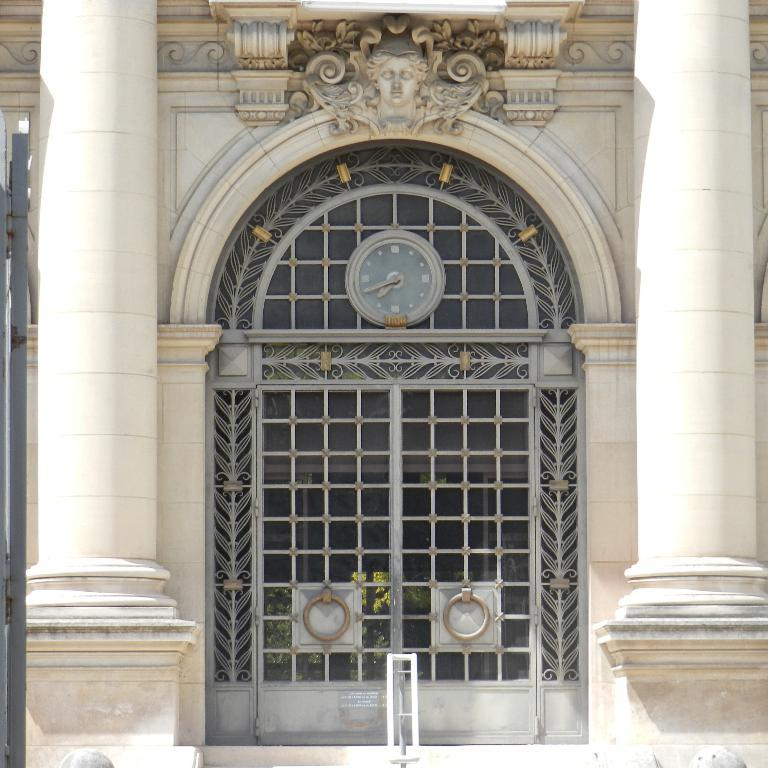What is the color of the door in the image? The door in the image is grey. What does the door lead to? The door leads to a building. Can you describe any features of the building? There is a statue of a person on top of the building. What architectural elements can be seen in the image? There are pillars visible in the image. What type of hen is sitting on the skirt in the image? There is no hen or skirt present in the image. What month is depicted on the calendar in the image? There is no calendar present in the image. 